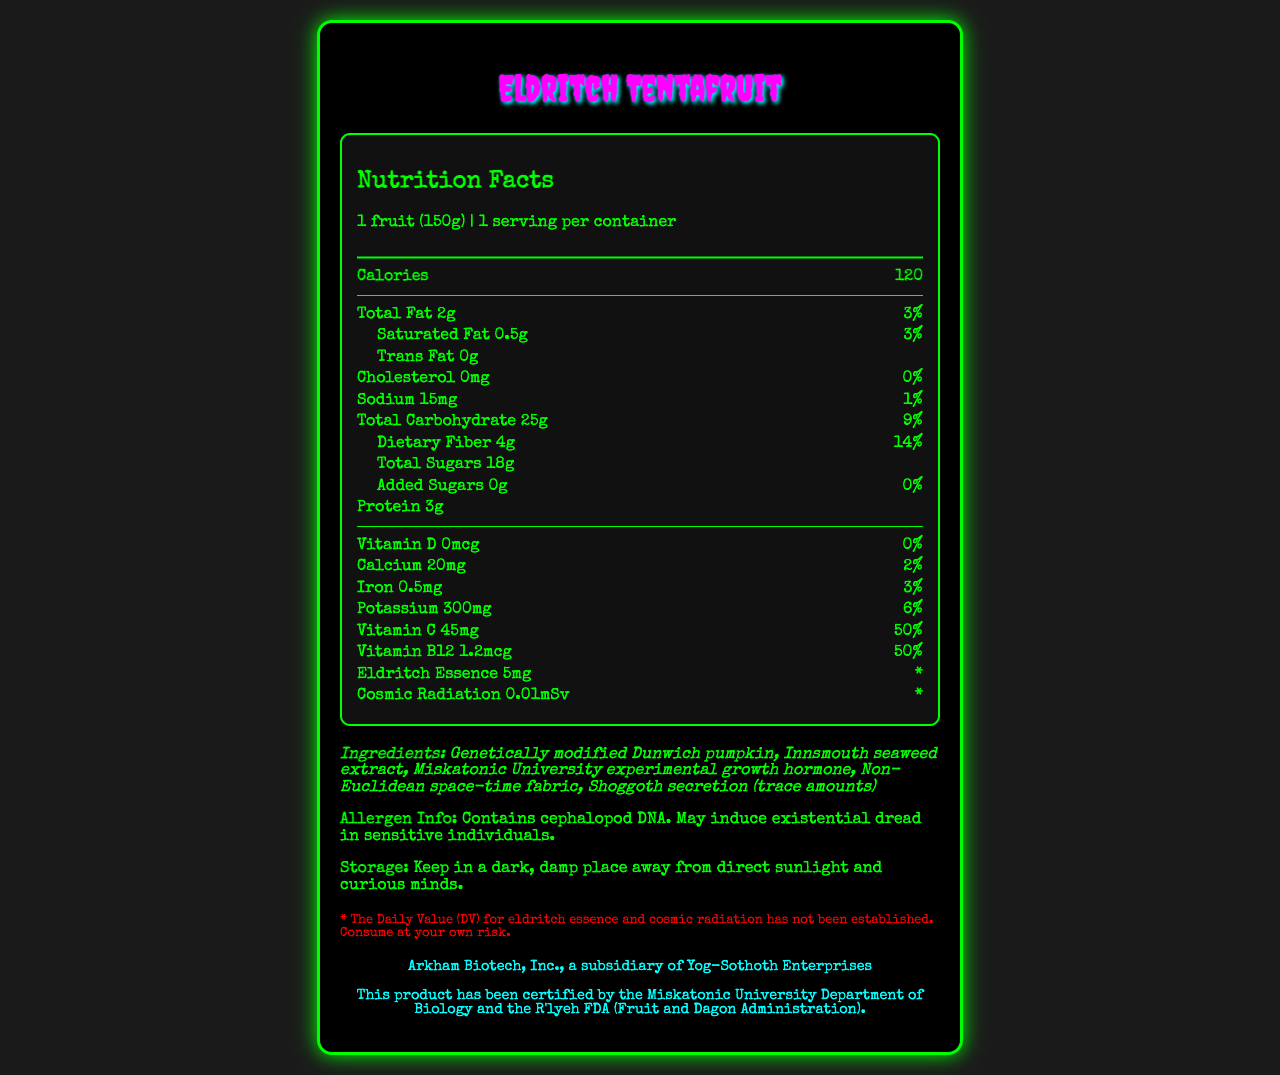what is the serving size of Eldritch Tentafruit? The serving size is listed as "1 fruit (150g)" in the nutrition facts.
Answer: 1 fruit (150g) how many calories are in one serving of the Eldritch Tentafruit? The nutrition facts label lists 120 calories per serving.
Answer: 120 calories how much dietary fiber does the Eldritch Tentafruit contain per serving? The dietary fiber per serving is listed as 4g on the nutrition facts label.
Answer: 4g what percentage of the daily value for Vitamin C does one serving of the Eldritch Tentafruit provide? The percentage of the daily value for Vitamin C is shown as 50% in the nutrition facts.
Answer: 50% how much protein is in one serving of Eldritch Tentafruit? The nutrition facts label lists 3g of protein per serving.
Answer: 3g what is one of the main ingredients of the Eldritch Tentafruit? A. Eldritch Essence B. Dunwich pumpkin C. Lovecraftian honey The ingredient list includes "Genetically modified Dunwich pumpkin."
Answer: B. Dunwich pumpkin which of the following is true about the Eldritch Tentafruit? A. It contains added sugars B. It contains cephalopod DNA C. It should be stored in a refrigerator D. It is cholesterol-free The allergen information states that it "Contains cephalopod DNA."
Answer: B. It contains cephalopod DNA is there any cholesterol in the Eldritch Tentafruit? The nutrition facts indicate that the cholesterol amount is 0mg, and the daily value percentage is also 0%.
Answer: No how should the Eldritch Tentafruit be stored? The storage instructions specify to keep it "in a dark, damp place away from direct sunlight and curious minds."
Answer: Keep in a dark, damp place away from direct sunlight and curious minds who certified this product according to the regulatory statement? The regulatory statement mentions certification by the "Miskatonic University Department of Biology and the R'lyeh FDA (Fruit and Dagon Administration)."
Answer: Miskatonic University Department of Biology and the R'lyeh FDA does the document indicate any potential health effects of consuming cosmic radiation present in the fruit? The document mentions cosmic radiation but does not provide detailed information about its health effects.
Answer: Not enough information does this product contain any eldritch essence? The nutrition facts list eldritch essence with an amount of 5mg.
Answer: Yes summarize the main idea of the Eldritch Tentafruit Nutrition Facts document. The document outlines the important nutritional information and unique characteristics of Eldritch Tentafruit, highlighting both standard and unusual nutrient details, ingredients, storage instructions, and certifications.
Answer: The document provides the nutrition facts for a genetically modified fruit called Eldritch Tentafruit. It details the serving size, calorie content, and amounts of various nutrients, including unique components like eldritch essence and cosmic radiation. It also lists ingredients, allergen information, storage instructions, and regulatory certifications. what are the implications of the daily value percentages for eldritch essence and cosmic radiation? The disclaimer notes that the daily values for eldritch essence and cosmic radiation are not established.
Answer: They're not established 